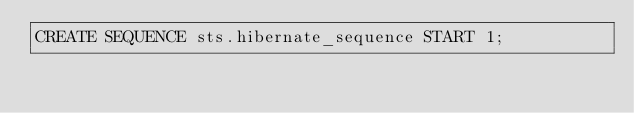<code> <loc_0><loc_0><loc_500><loc_500><_SQL_>CREATE SEQUENCE sts.hibernate_sequence START 1;
</code> 